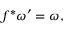<formula> <loc_0><loc_0><loc_500><loc_500>f ^ { * } \omega ^ { \prime } = \omega ,</formula> 